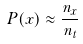Convert formula to latex. <formula><loc_0><loc_0><loc_500><loc_500>P ( x ) \approx \frac { n _ { x } } { n _ { t } }</formula> 